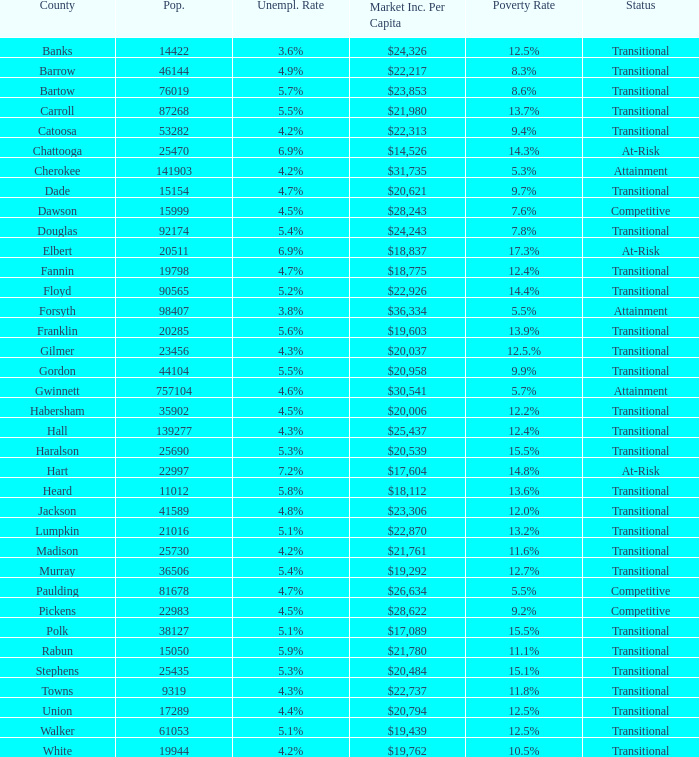What is the status of the county that has a 17.3% poverty rate? At-Risk. 